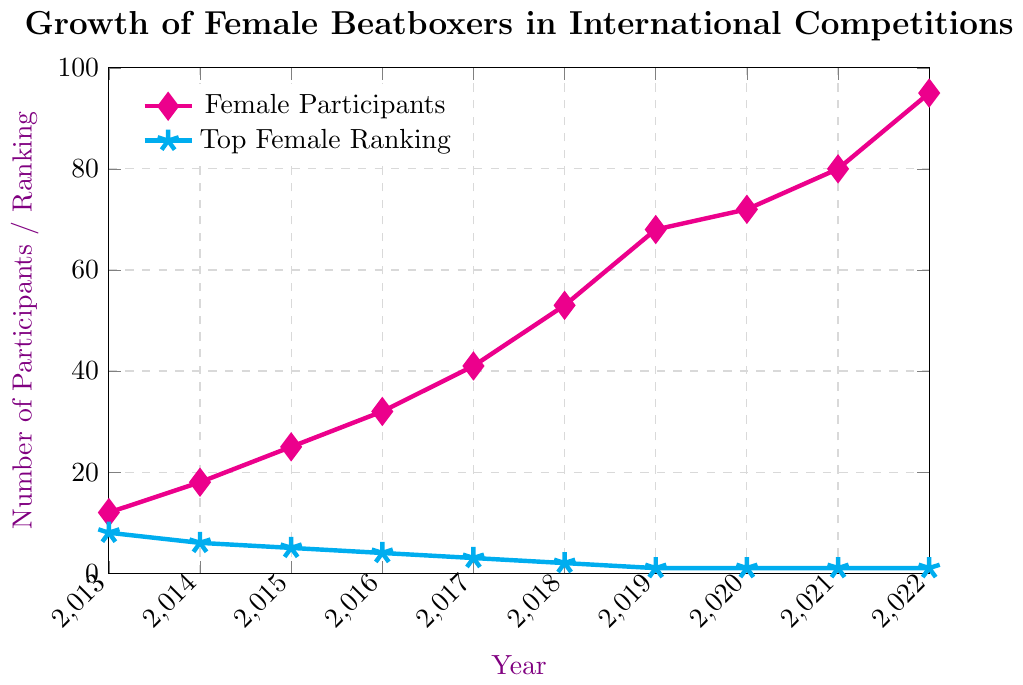What's the trend for the number of female participants from 2013 to 2022? The number of female participants has consistently increased each year from 2013 (12 participants) to 2022 (95 participants).
Answer: Increasing How many more female participants were there in 2022 compared to 2013? In 2022, there were 95 female participants and in 2013, there were 12. The difference between 2022 and 2013 is 95 - 12 = 83.
Answer: 83 What year did the number of female participants first exceed 50? The number of female participants exceeded 50 for the first time in the year 2018. Checking the values, in 2018, there were 53 participants.
Answer: 2018 How has the top female ranking changed from 2013 to 2022? The top female ranking has improved over time. In 2013, the top ranking was 8, and it improved to 1 by 2019 and remained there till 2022.
Answer: Improved from 8 to 1 Compare the rate of increase in female participants between the periods 2013-2017 and 2017-2022. Which period had a higher increase rate? From 2013 to 2017, the number of participants increased from 12 to 41, a difference of 29 over 4 years. From 2017 to 2022, participants increased from 41 to 95, a difference of 54 over 5 years. The rate of increase is higher in the second period.
Answer: 2017-2022 What was the average number of female participants from 2013 to 2017? Adding participants: 12 (2013) + 18 (2014) + 25 (2015) + 32 (2016) + 41 (2017) = 128, dividing by 5 years, 128 / 5 = 25.6.
Answer: 25.6 At what year did the top-ranking female beatboxer rank Number 1 for the first time? The top-ranking female beatboxer achieved the Number 1 rank for the first time in the year 2019.
Answer: 2019 What is the visual difference in the markers representing the female participants and the top female ranking? The female participants are represented by magenta diamond shapes, while the top female ranking is represented by cyan star shapes.
Answer: Magenta diamonds for participants, cyan stars for ranking How many years did it take for the top female ranking to reach Number 1 from the starting data point in 2013? It took from 2013 to 2019 for the top female ranking to reach Number 1. Counting the years: 2013, 2014, 2015, 2016, 2017, 2018, 2019, it took 6 years.
Answer: 6 years 